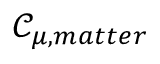<formula> <loc_0><loc_0><loc_500><loc_500>\mathcal { C } _ { \mu , m a t t e r }</formula> 